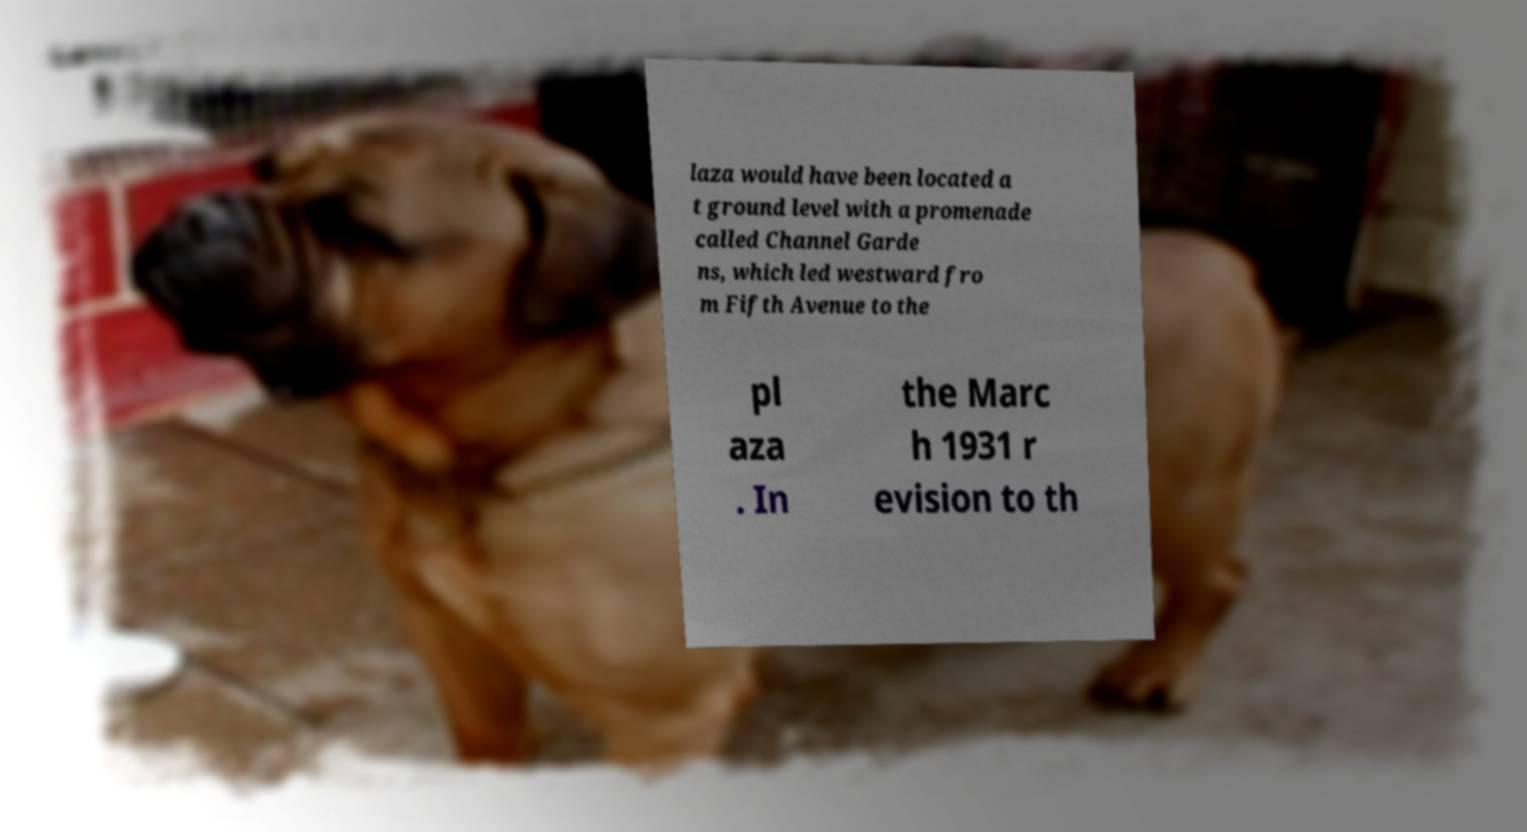Can you read and provide the text displayed in the image?This photo seems to have some interesting text. Can you extract and type it out for me? laza would have been located a t ground level with a promenade called Channel Garde ns, which led westward fro m Fifth Avenue to the pl aza . In the Marc h 1931 r evision to th 